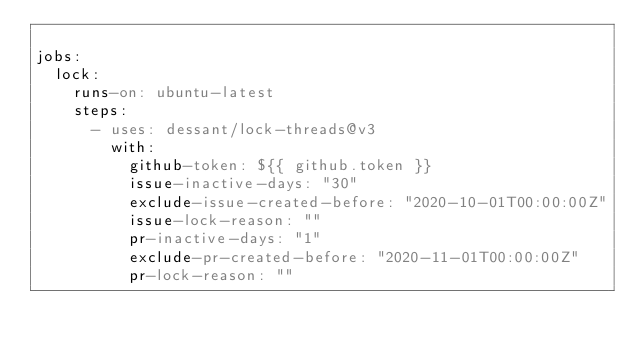<code> <loc_0><loc_0><loc_500><loc_500><_YAML_>
jobs:
  lock:
    runs-on: ubuntu-latest
    steps:
      - uses: dessant/lock-threads@v3
        with:
          github-token: ${{ github.token }}
          issue-inactive-days: "30"
          exclude-issue-created-before: "2020-10-01T00:00:00Z"
          issue-lock-reason: ""
          pr-inactive-days: "1"
          exclude-pr-created-before: "2020-11-01T00:00:00Z"
          pr-lock-reason: ""
</code> 